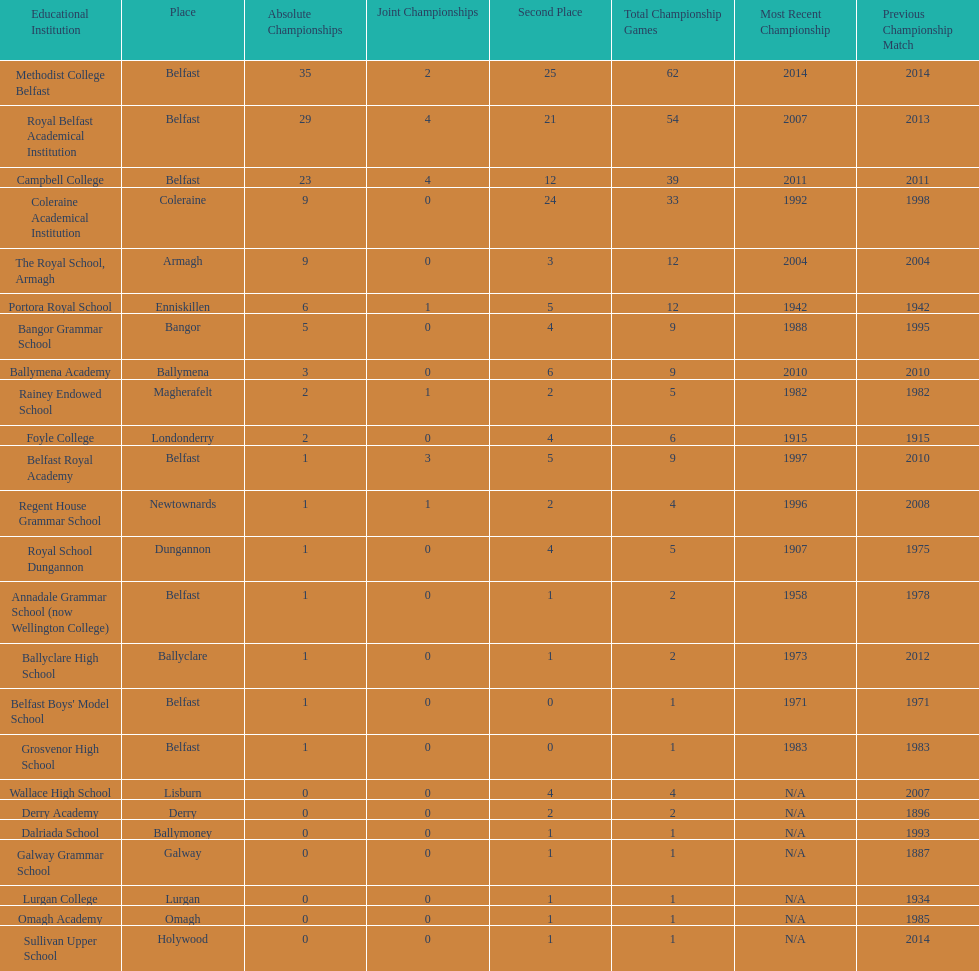Did belfast royal academy have more or less total finals than ballyclare high school? More. 